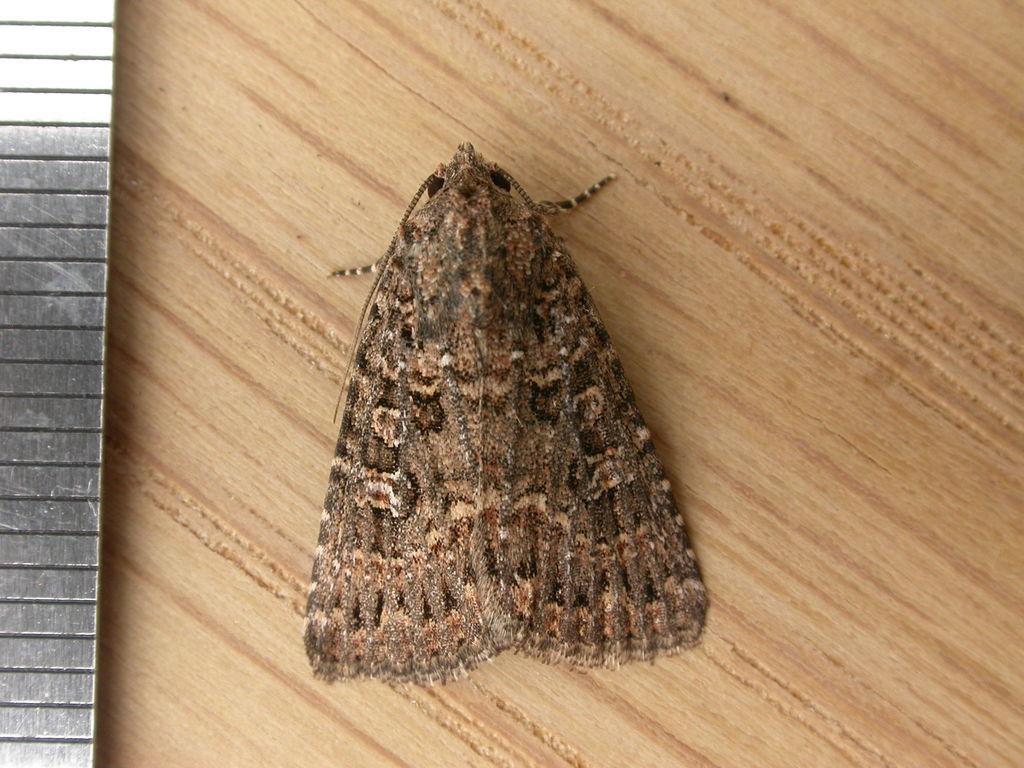How would you summarize this image in a sentence or two? In the center of the image there is a fly on the wall. 